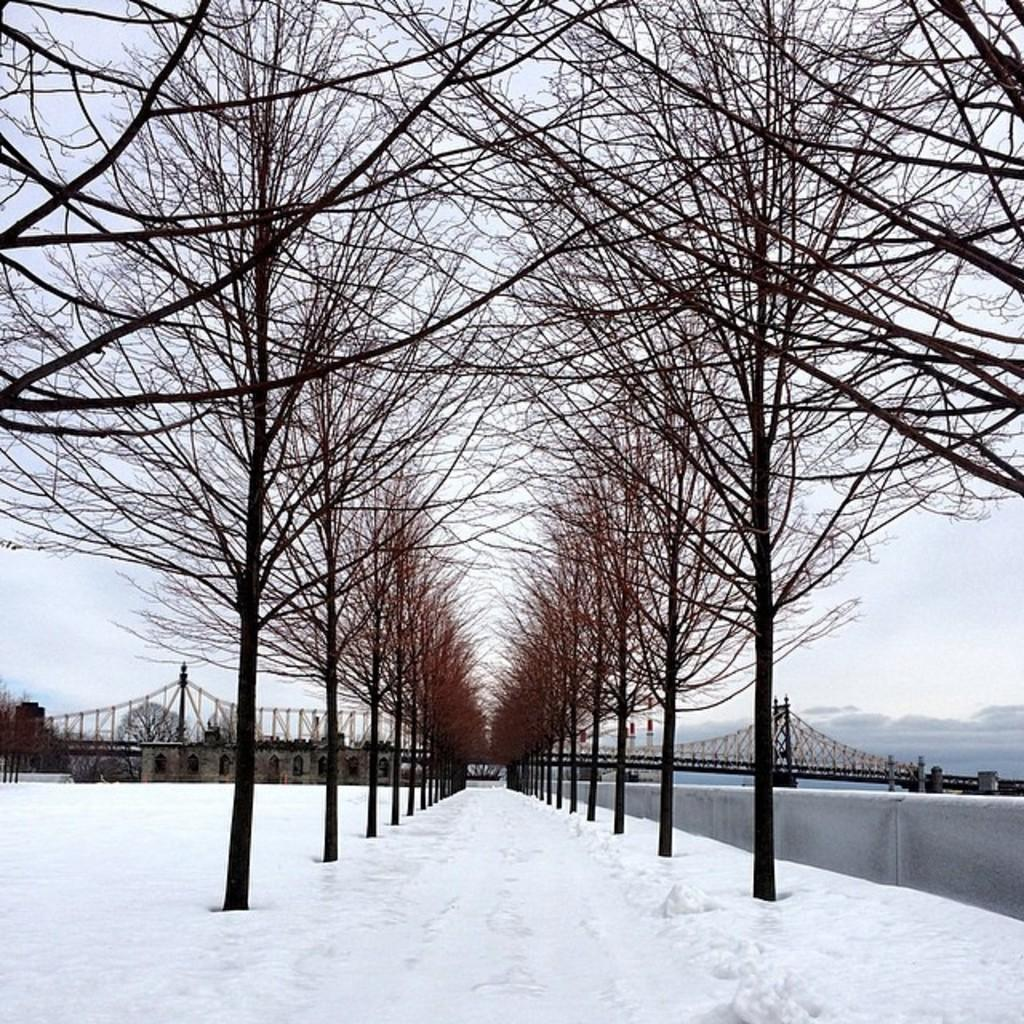What type of structure can be seen in the image? There is a building in the image. What other man-made feature is present in the image? There is a bridge in the image. What natural elements are visible in the image? There are trees, the sky, clouds, snow, and water in the image. Can you see a fan in the image? There is no fan present in the image. How many toads are sitting on the bridge in the image? There are no toads present in the image. 